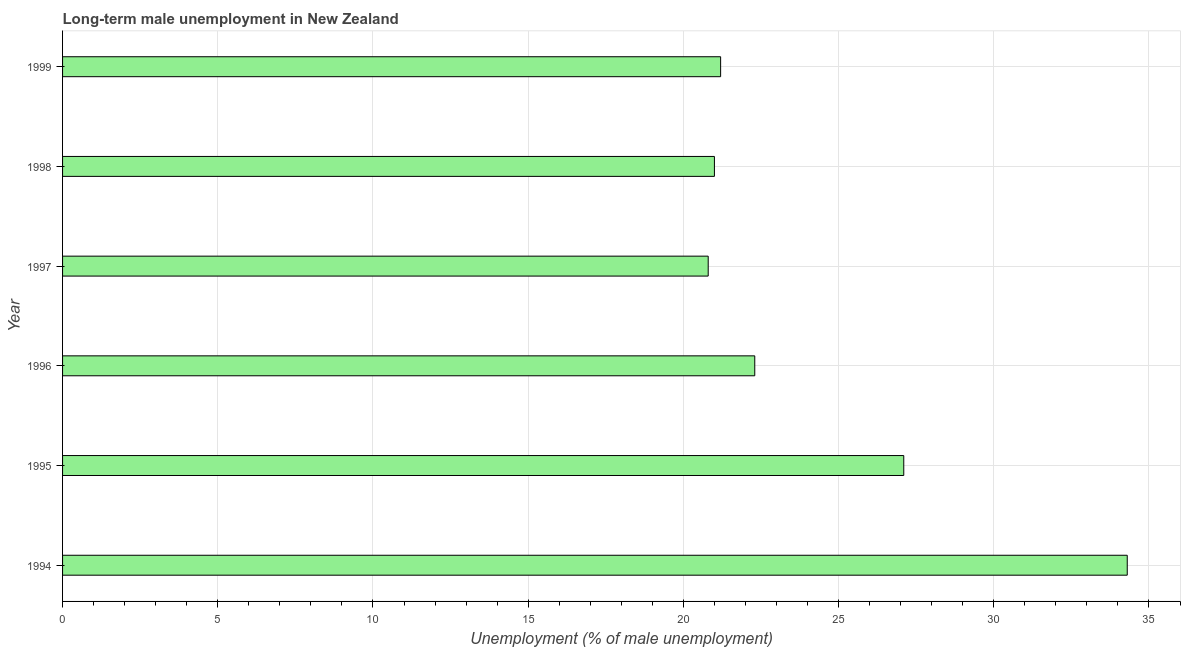Does the graph contain grids?
Ensure brevity in your answer.  Yes. What is the title of the graph?
Ensure brevity in your answer.  Long-term male unemployment in New Zealand. What is the label or title of the X-axis?
Keep it short and to the point. Unemployment (% of male unemployment). What is the label or title of the Y-axis?
Your response must be concise. Year. What is the long-term male unemployment in 1996?
Offer a very short reply. 22.3. Across all years, what is the maximum long-term male unemployment?
Keep it short and to the point. 34.3. Across all years, what is the minimum long-term male unemployment?
Provide a succinct answer. 20.8. In which year was the long-term male unemployment minimum?
Ensure brevity in your answer.  1997. What is the sum of the long-term male unemployment?
Your answer should be compact. 146.7. What is the average long-term male unemployment per year?
Provide a short and direct response. 24.45. What is the median long-term male unemployment?
Give a very brief answer. 21.75. In how many years, is the long-term male unemployment greater than 30 %?
Your response must be concise. 1. What is the ratio of the long-term male unemployment in 1997 to that in 1999?
Give a very brief answer. 0.98. Is the long-term male unemployment in 1995 less than that in 1998?
Give a very brief answer. No. What is the difference between the highest and the second highest long-term male unemployment?
Ensure brevity in your answer.  7.2. Is the sum of the long-term male unemployment in 1996 and 1998 greater than the maximum long-term male unemployment across all years?
Offer a terse response. Yes. What is the difference between the highest and the lowest long-term male unemployment?
Give a very brief answer. 13.5. In how many years, is the long-term male unemployment greater than the average long-term male unemployment taken over all years?
Your answer should be very brief. 2. Are all the bars in the graph horizontal?
Keep it short and to the point. Yes. What is the difference between two consecutive major ticks on the X-axis?
Your answer should be very brief. 5. Are the values on the major ticks of X-axis written in scientific E-notation?
Ensure brevity in your answer.  No. What is the Unemployment (% of male unemployment) in 1994?
Keep it short and to the point. 34.3. What is the Unemployment (% of male unemployment) of 1995?
Provide a short and direct response. 27.1. What is the Unemployment (% of male unemployment) of 1996?
Your answer should be very brief. 22.3. What is the Unemployment (% of male unemployment) in 1997?
Make the answer very short. 20.8. What is the Unemployment (% of male unemployment) in 1998?
Ensure brevity in your answer.  21. What is the Unemployment (% of male unemployment) of 1999?
Give a very brief answer. 21.2. What is the difference between the Unemployment (% of male unemployment) in 1994 and 1996?
Make the answer very short. 12. What is the difference between the Unemployment (% of male unemployment) in 1994 and 1997?
Keep it short and to the point. 13.5. What is the difference between the Unemployment (% of male unemployment) in 1994 and 1998?
Provide a short and direct response. 13.3. What is the difference between the Unemployment (% of male unemployment) in 1994 and 1999?
Make the answer very short. 13.1. What is the difference between the Unemployment (% of male unemployment) in 1995 and 1996?
Keep it short and to the point. 4.8. What is the difference between the Unemployment (% of male unemployment) in 1995 and 1998?
Keep it short and to the point. 6.1. What is the difference between the Unemployment (% of male unemployment) in 1996 and 1998?
Provide a short and direct response. 1.3. What is the difference between the Unemployment (% of male unemployment) in 1998 and 1999?
Keep it short and to the point. -0.2. What is the ratio of the Unemployment (% of male unemployment) in 1994 to that in 1995?
Your answer should be compact. 1.27. What is the ratio of the Unemployment (% of male unemployment) in 1994 to that in 1996?
Ensure brevity in your answer.  1.54. What is the ratio of the Unemployment (% of male unemployment) in 1994 to that in 1997?
Your answer should be compact. 1.65. What is the ratio of the Unemployment (% of male unemployment) in 1994 to that in 1998?
Your answer should be compact. 1.63. What is the ratio of the Unemployment (% of male unemployment) in 1994 to that in 1999?
Your answer should be compact. 1.62. What is the ratio of the Unemployment (% of male unemployment) in 1995 to that in 1996?
Give a very brief answer. 1.22. What is the ratio of the Unemployment (% of male unemployment) in 1995 to that in 1997?
Give a very brief answer. 1.3. What is the ratio of the Unemployment (% of male unemployment) in 1995 to that in 1998?
Provide a short and direct response. 1.29. What is the ratio of the Unemployment (% of male unemployment) in 1995 to that in 1999?
Provide a succinct answer. 1.28. What is the ratio of the Unemployment (% of male unemployment) in 1996 to that in 1997?
Provide a short and direct response. 1.07. What is the ratio of the Unemployment (% of male unemployment) in 1996 to that in 1998?
Provide a short and direct response. 1.06. What is the ratio of the Unemployment (% of male unemployment) in 1996 to that in 1999?
Give a very brief answer. 1.05. What is the ratio of the Unemployment (% of male unemployment) in 1997 to that in 1998?
Your response must be concise. 0.99. 